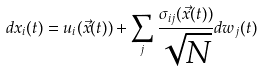Convert formula to latex. <formula><loc_0><loc_0><loc_500><loc_500>d x _ { i } ( t ) = u _ { i } ( { \vec { x } } ( t ) ) + \sum _ { j } \frac { \sigma _ { i j } ( { \vec { x } } ( t ) ) } { \sqrt { N } } d w _ { j } ( t )</formula> 